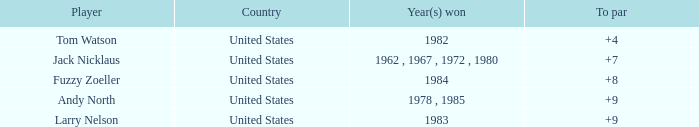Would you be able to parse every entry in this table? {'header': ['Player', 'Country', 'Year(s) won', 'To par'], 'rows': [['Tom Watson', 'United States', '1982', '+4'], ['Jack Nicklaus', 'United States', '1962 , 1967 , 1972 , 1980', '+7'], ['Fuzzy Zoeller', 'United States', '1984', '+8'], ['Andy North', 'United States', '1978 , 1985', '+9'], ['Larry Nelson', 'United States', '1983', '+9']]} What is the aggregate for the player with a to par of 4? 1.0. 